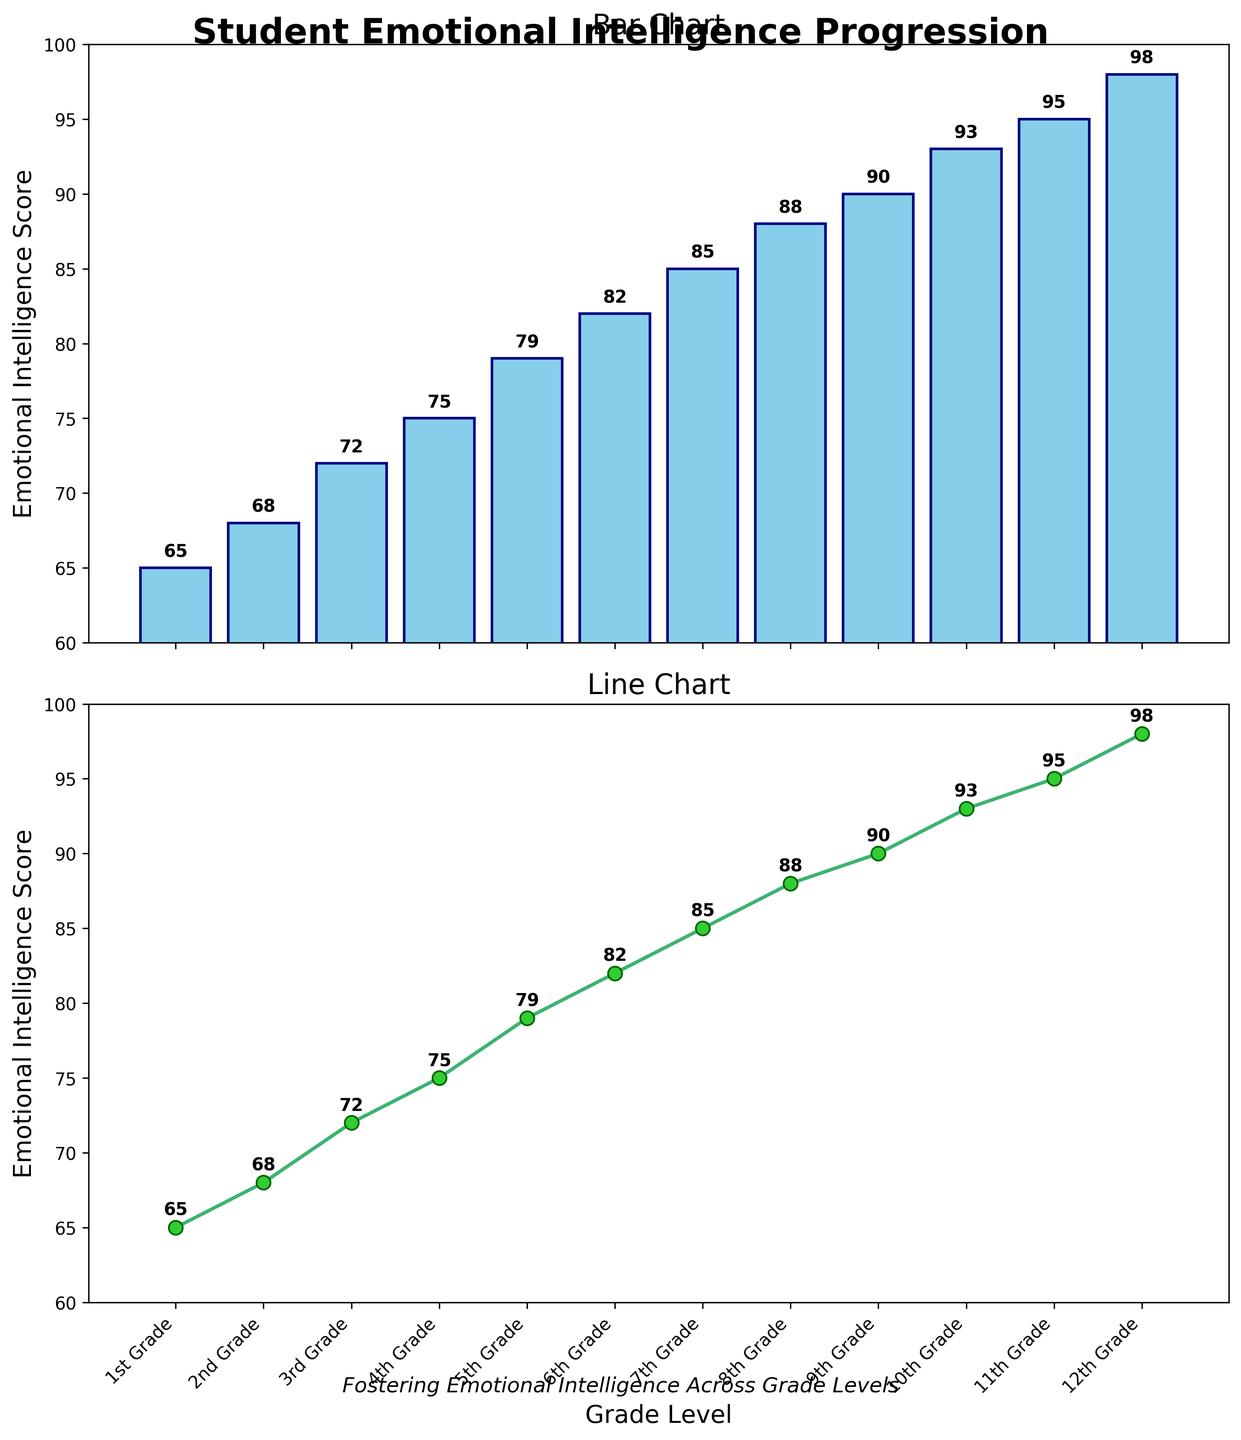what's the title of the figure? The title of the figure is shown at the top of the plot. It reads "Student Emotional Intelligence Progression" in bold.
Answer: Student Emotional Intelligence Progression what's the range of emotional intelligence scores depicted in the bar chart? In the bar chart, the Y-axis starts at 60 and ends at 100, indicating the range of emotional intelligence scores being depicted.
Answer: 60 to 100 what is the emotional intelligence score for 5th-grade students? The bar for 5th Grade shows a score at the Y-axis, and the text label above the bar confirms it.
Answer: 79 whose emotional intelligence score is highest in the line chart? The line chart shows a steady progression, and the highest point on the line is at the 12th grade with an annotated score of 98.
Answer: 12th Grade Which grade level shows a score increase of 7 points from the previous grade? Comparing the emotional intelligence scores between consecutive grades in the charts, the 10th Grade increases from 90 to 97, a 7-point jump.
Answer: 10th Grade By how many points does the emotional intelligence score increase from 1st grade to 12th grade? The score in 1st grade is 65 and it increases to 98 in 12th grade. Subtracting, we find 98 - 65 = 33.
Answer: 33 what is the average emotional intelligence score across all grade levels? To find the average, add all scores (65+68+72+75+79+82+85+88+90+93+95+98 = 990) and divide by the number of grades (12). The average is 990 / 12.
Answer: 82.5 Which grade level shows the smallest increase in emotional intelligence score compared to its previous grade? Comparing sequential differences: (3, 4, 3, 3, 3, 3, 3, 2, 3, 2), the smallest difference is between 8th and 9th Grade, increasing by just 2 points.
Answer: 9th Grade what is the purpose of including both a bar chart and a line chart in the figure? The bar chart helps to identify individual emotional intelligence scores by grade, while the line chart helps to visualize the overall trend and progression across grades.
Answer: To show individual scores and the overall trend 